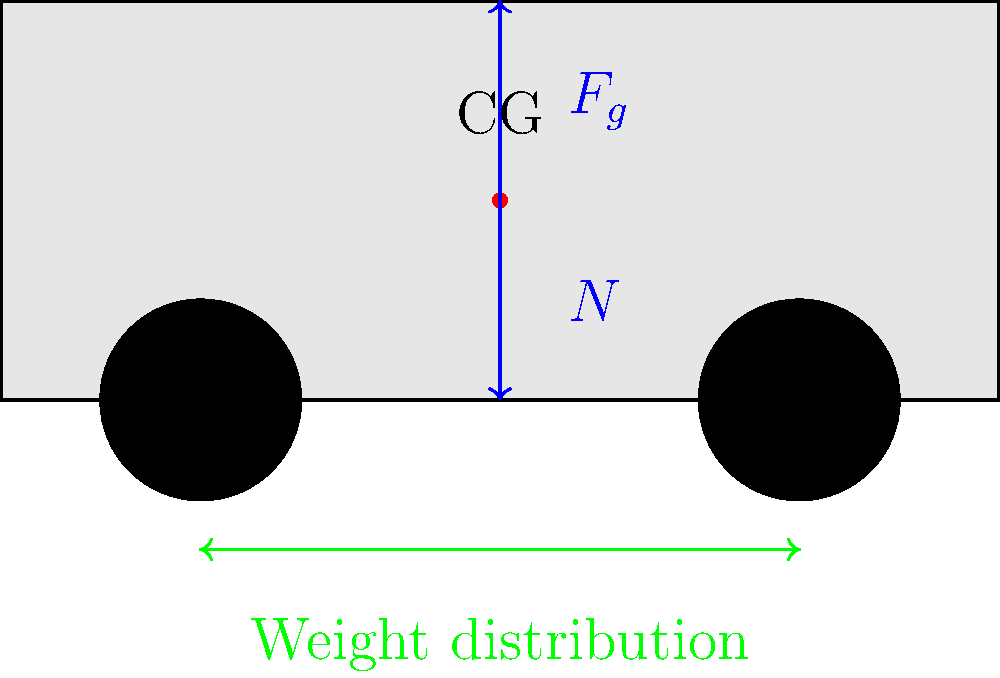As a car salesman emphasizing safety features for family vehicles, explain how the distribution of weight in a car affects its stability during cornering. Use the diagram to support your explanation, considering the center of gravity (CG) and the forces acting on the vehicle. 1. Center of Gravity (CG): The red dot in the diagram represents the car's center of gravity. This is the point where the car's weight is evenly distributed.

2. Weight Distribution: The green arrows at the bottom of the diagram show the weight distribution between the front and rear of the vehicle.

3. Forces: 
   - $F_g$: The blue downward arrow represents the gravitational force acting on the car's CG.
   - $N$: The blue upward arrow represents the normal force from the ground.

4. During cornering:
   - The car experiences a centrifugal force pushing it outward.
   - This force creates a moment around the CG, which can cause the car to roll.

5. Stability factors:
   - Lower CG: A lower CG (closer to the ground) reduces the rolling moment, increasing stability.
   - Wider stance: A wider distance between wheels provides more resistance to rolling.
   - Even weight distribution: Balanced weight between front and rear improves overall stability.

6. Safety implications:
   - Cars with a lower CG and wider stance are generally more stable during cornering.
   - SUVs and tall vehicles often have a higher CG, which can increase rollover risk.
   - Weight distribution affects braking and acceleration performance.

7. For family vehicles:
   - Look for cars with a lower profile and wider wheelbase for improved stability.
   - Consider vehicles with advanced stability control systems to enhance safety during cornering.
   - Emphasize the importance of proper loading to maintain intended weight distribution.
Answer: Lower center of gravity, wider stance, and even weight distribution improve a car's stability during cornering, enhancing safety for family vehicles. 